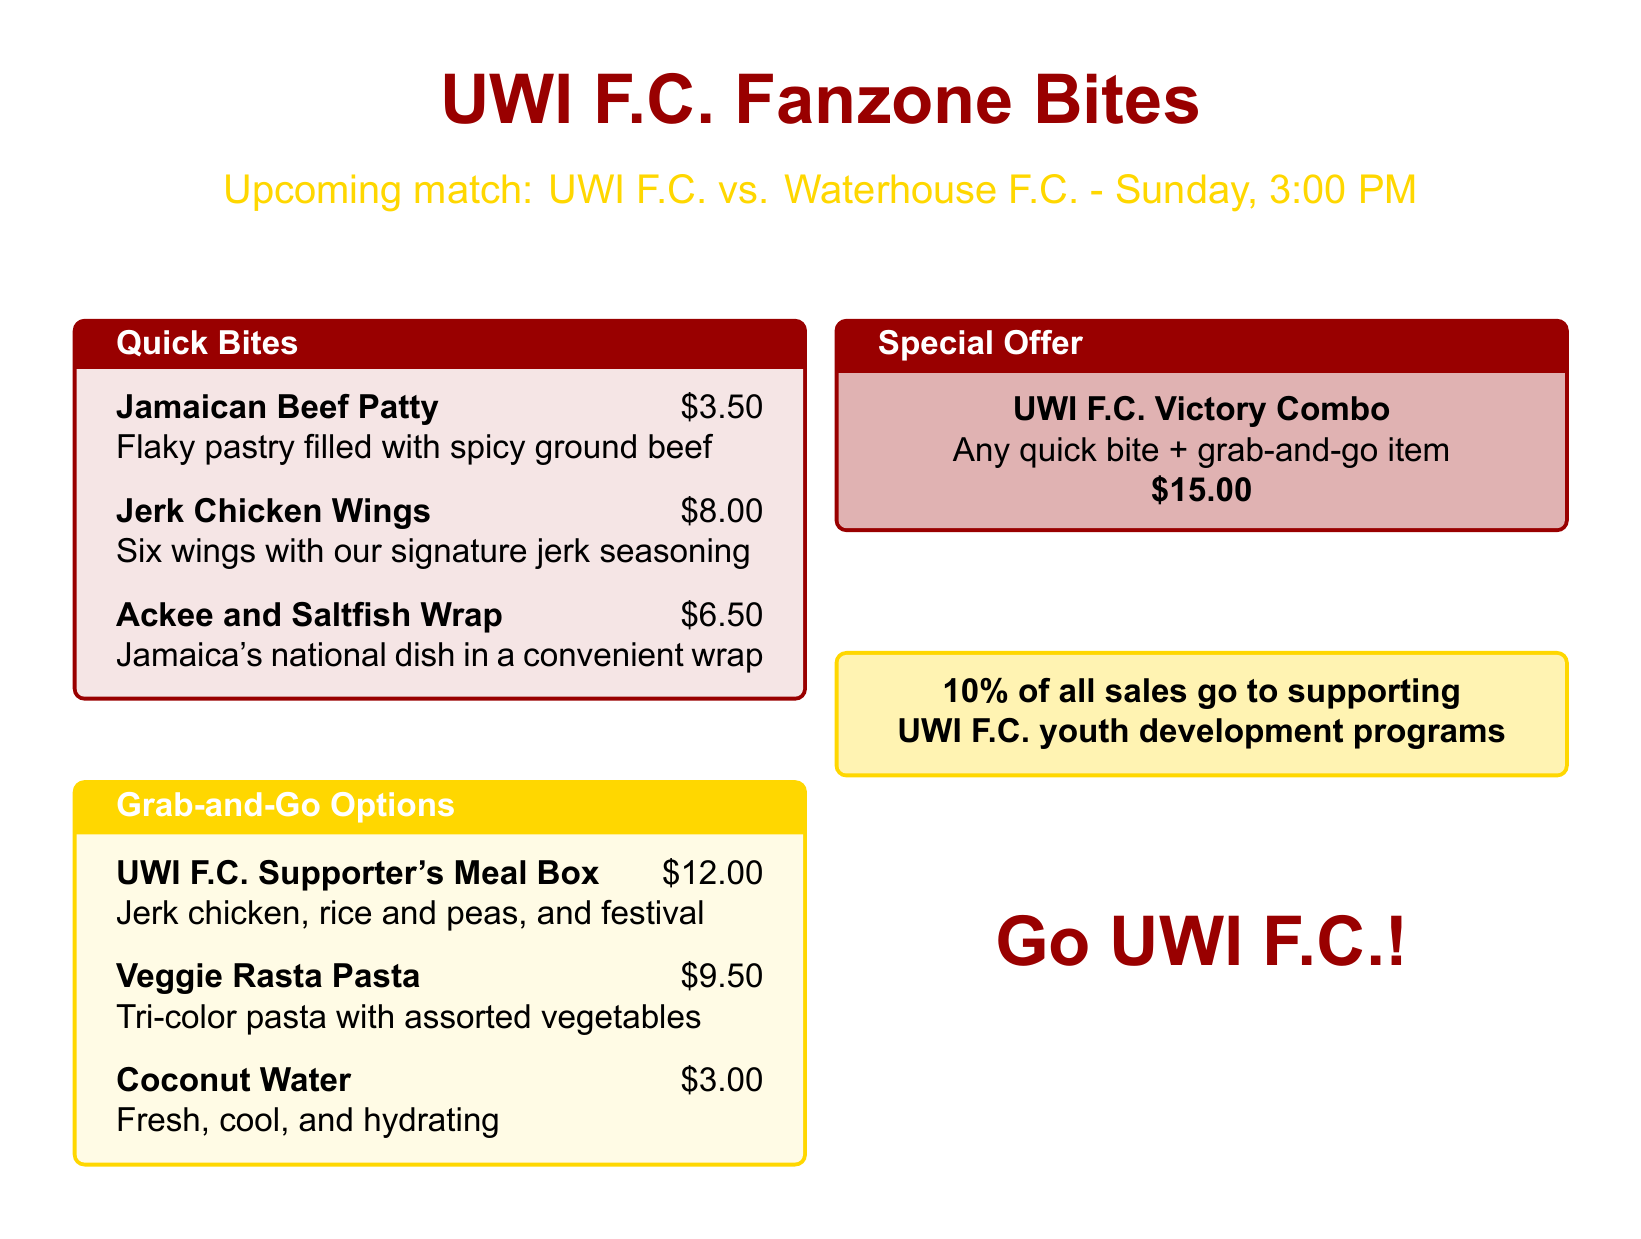What is the title of the menu? The title is prominently displayed at the center of the document.
Answer: UWI F.C. Fanzone Bites What is the price of a Jamaican Beef Patty? The price is listed next to the food item in the Quick Bites section.
Answer: $3.50 What dish features Jamaica's national dish in a wrap? This information is found in the Quick Bites section, describing a specific dish.
Answer: Ackee and Saltfish Wrap What are the components of the UWI F.C. Supporter's Meal Box? The meal box contains specific items described in the Grab-and-Go Options.
Answer: Jerk chicken, rice and peas, and festival What is the special offer available on the menu? The special offer is highlighted in a separate box and explains a combo deal.
Answer: UWI F.C. Victory Combo What percentage of sales supports UWI F.C. youth development programs? The percentage is stated in a promotional section at the bottom of the menu.
Answer: 10% What is the price of the Veggie Rasta Pasta? This is found in the Grab-and-Go Options section, along with its description.
Answer: $9.50 When is the upcoming match mentioned in the menu? The date and time of the match are provided near the title of the menu.
Answer: Sunday, 3:00 PM What drink is offered for $3.00? This information is found in the Grab-and-Go Options section.
Answer: Coconut Water 